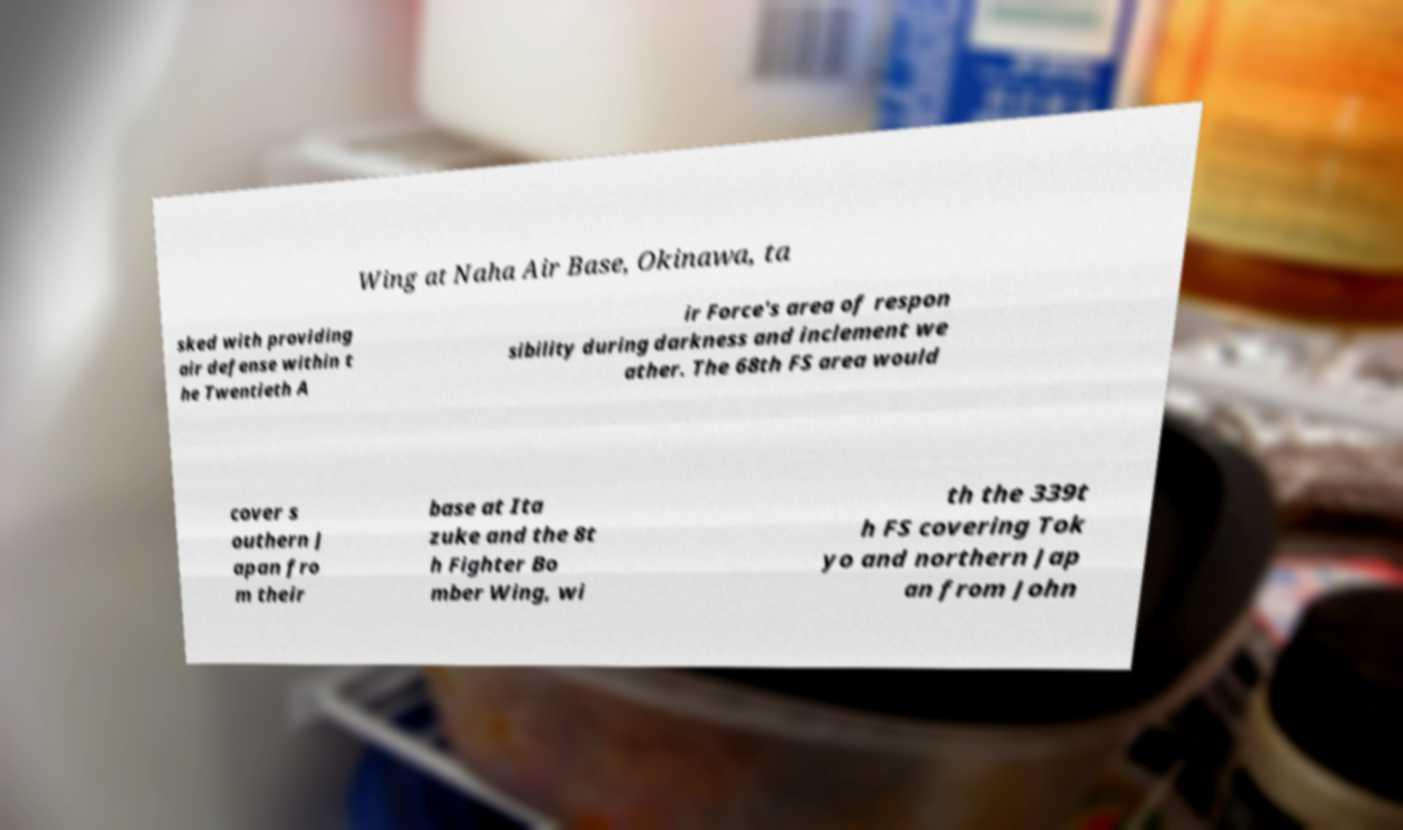Could you assist in decoding the text presented in this image and type it out clearly? Wing at Naha Air Base, Okinawa, ta sked with providing air defense within t he Twentieth A ir Force's area of respon sibility during darkness and inclement we ather. The 68th FS area would cover s outhern J apan fro m their base at Ita zuke and the 8t h Fighter Bo mber Wing, wi th the 339t h FS covering Tok yo and northern Jap an from John 